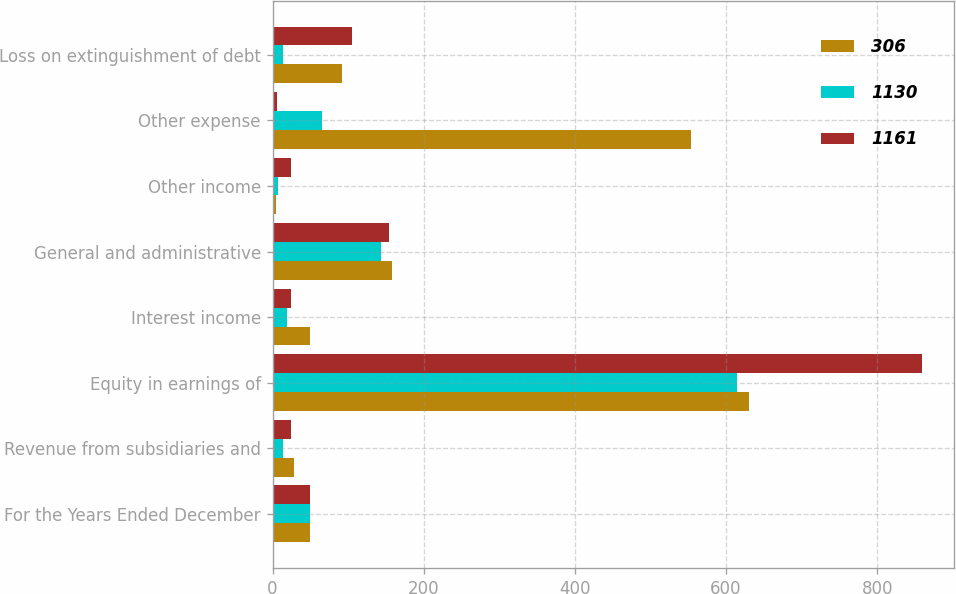<chart> <loc_0><loc_0><loc_500><loc_500><stacked_bar_chart><ecel><fcel>For the Years Ended December<fcel>Revenue from subsidiaries and<fcel>Equity in earnings of<fcel>Interest income<fcel>General and administrative<fcel>Other income<fcel>Other expense<fcel>Loss on extinguishment of debt<nl><fcel>306<fcel>49<fcel>28<fcel>630<fcel>49<fcel>158<fcel>5<fcel>554<fcel>92<nl><fcel>1130<fcel>49<fcel>14<fcel>615<fcel>19<fcel>144<fcel>7<fcel>65<fcel>14<nl><fcel>1161<fcel>49<fcel>24<fcel>859<fcel>24<fcel>154<fcel>24<fcel>6<fcel>105<nl></chart> 